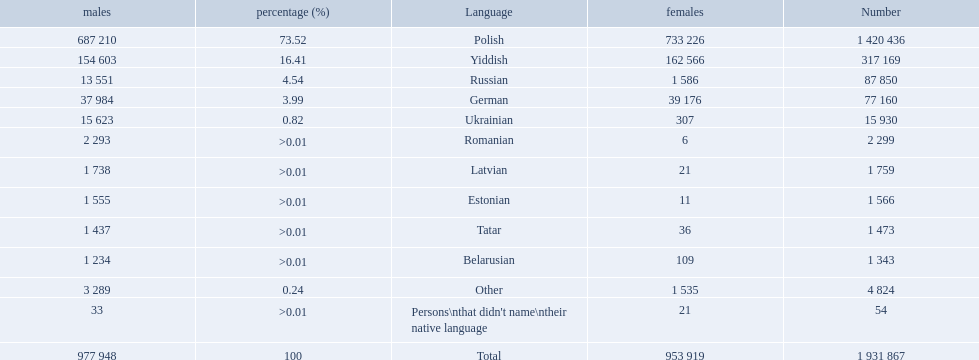What languages are spoken in the warsaw governorate? Polish, Yiddish, Russian, German, Ukrainian, Romanian, Latvian, Estonian, Tatar, Belarusian. Which are the top five languages? Polish, Yiddish, Russian, German, Ukrainian. Of those which is the 2nd most frequently spoken? Yiddish. What are all the spoken languages? Polish, Yiddish, Russian, German, Ukrainian, Romanian, Latvian, Estonian, Tatar, Belarusian. Which one of these has the most people speaking it? Polish. 